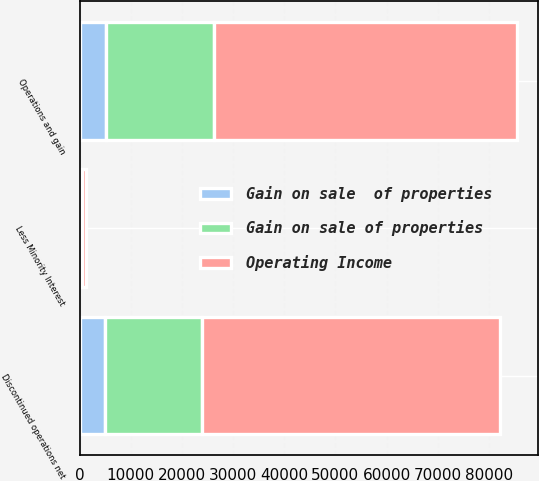Convert chart to OTSL. <chart><loc_0><loc_0><loc_500><loc_500><stacked_bar_chart><ecel><fcel>Operations and gain<fcel>Less Minority Interest<fcel>Discontinued operations net<nl><fcel>Gain on sale  of properties<fcel>5067<fcel>68<fcel>4999<nl><fcel>Operating Income<fcel>59181<fcel>814<fcel>58367<nl><fcel>Gain on sale of properties<fcel>21151<fcel>344<fcel>18876<nl></chart> 